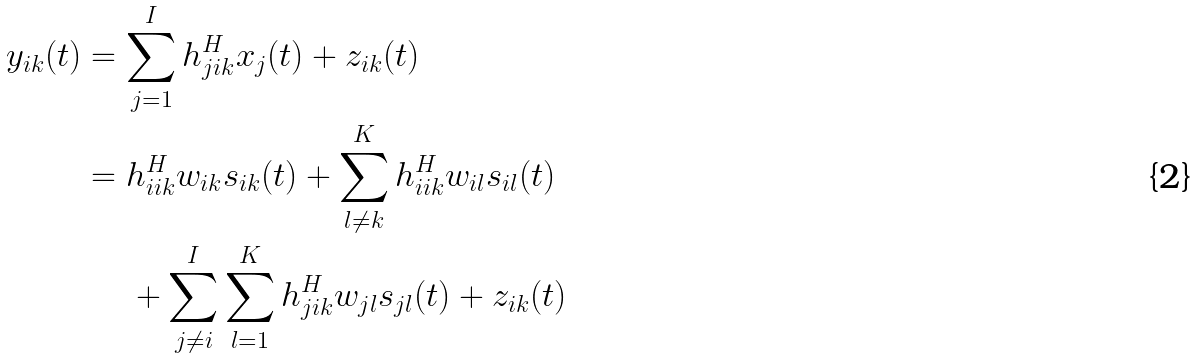Convert formula to latex. <formula><loc_0><loc_0><loc_500><loc_500>y _ { i k } ( t ) & = \sum _ { j = 1 } ^ { I } { h _ { j i k } ^ { H } x _ { j } ( t ) } + z _ { i k } ( t ) \\ & = h _ { i i k } ^ { H } w _ { i k } s _ { i k } ( t ) + \sum _ { l \neq k } ^ { K } { h _ { i i k } ^ { H } w _ { i l } s _ { i l } ( t ) } \\ & \quad \ + \sum _ { j \neq i } ^ { I } { \sum _ { l = 1 } ^ { K } { h _ { j i k } ^ { H } w _ { j l } s _ { j l } ( t ) } } + z _ { i k } ( t )</formula> 